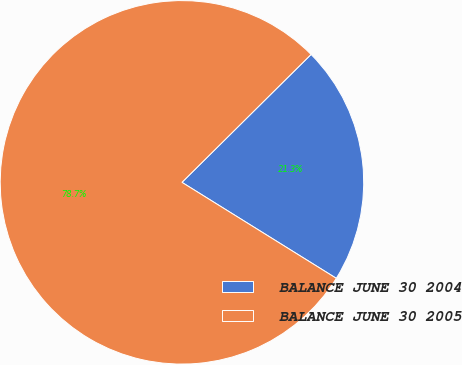<chart> <loc_0><loc_0><loc_500><loc_500><pie_chart><fcel>BALANCE JUNE 30 2004<fcel>BALANCE JUNE 30 2005<nl><fcel>21.28%<fcel>78.72%<nl></chart> 